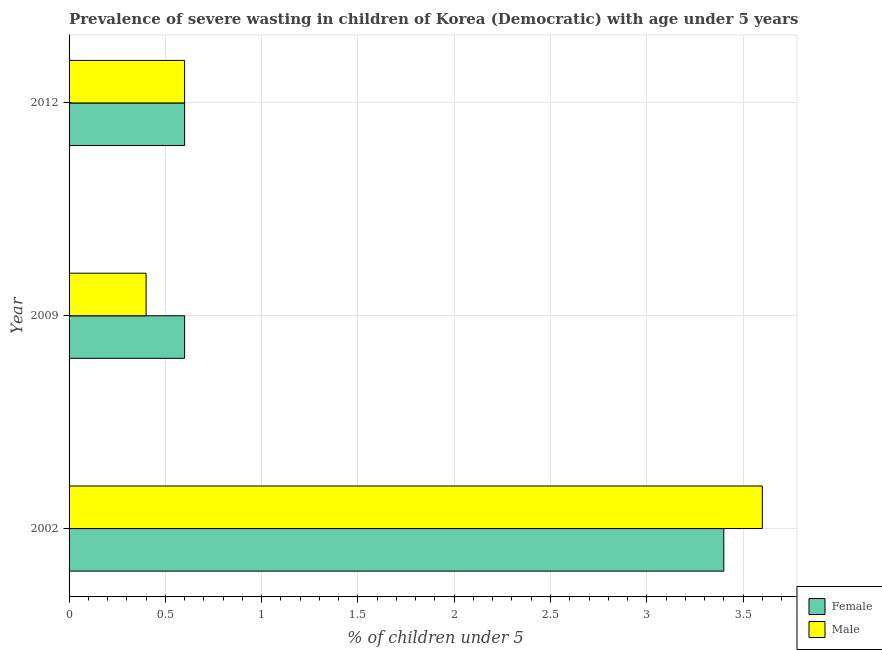How many different coloured bars are there?
Provide a short and direct response. 2. What is the label of the 2nd group of bars from the top?
Your answer should be compact. 2009. What is the percentage of undernourished female children in 2012?
Give a very brief answer. 0.6. Across all years, what is the maximum percentage of undernourished female children?
Give a very brief answer. 3.4. Across all years, what is the minimum percentage of undernourished male children?
Keep it short and to the point. 0.4. In which year was the percentage of undernourished female children maximum?
Provide a short and direct response. 2002. What is the total percentage of undernourished male children in the graph?
Make the answer very short. 4.6. What is the difference between the percentage of undernourished female children in 2009 and the percentage of undernourished male children in 2002?
Make the answer very short. -3. What is the average percentage of undernourished male children per year?
Provide a short and direct response. 1.53. In the year 2009, what is the difference between the percentage of undernourished male children and percentage of undernourished female children?
Offer a very short reply. -0.2. Is the percentage of undernourished male children in 2002 less than that in 2009?
Provide a short and direct response. No. In how many years, is the percentage of undernourished male children greater than the average percentage of undernourished male children taken over all years?
Offer a very short reply. 1. Is the sum of the percentage of undernourished male children in 2009 and 2012 greater than the maximum percentage of undernourished female children across all years?
Ensure brevity in your answer.  No. How many bars are there?
Your answer should be very brief. 6. How many years are there in the graph?
Provide a short and direct response. 3. Are the values on the major ticks of X-axis written in scientific E-notation?
Give a very brief answer. No. Does the graph contain any zero values?
Ensure brevity in your answer.  No. Where does the legend appear in the graph?
Give a very brief answer. Bottom right. What is the title of the graph?
Your answer should be compact. Prevalence of severe wasting in children of Korea (Democratic) with age under 5 years. Does "2012 US$" appear as one of the legend labels in the graph?
Your response must be concise. No. What is the label or title of the X-axis?
Give a very brief answer.  % of children under 5. What is the  % of children under 5 of Female in 2002?
Your answer should be very brief. 3.4. What is the  % of children under 5 of Male in 2002?
Your response must be concise. 3.6. What is the  % of children under 5 of Female in 2009?
Give a very brief answer. 0.6. What is the  % of children under 5 in Male in 2009?
Your answer should be very brief. 0.4. What is the  % of children under 5 of Female in 2012?
Give a very brief answer. 0.6. What is the  % of children under 5 in Male in 2012?
Your answer should be very brief. 0.6. Across all years, what is the maximum  % of children under 5 in Female?
Your response must be concise. 3.4. Across all years, what is the maximum  % of children under 5 in Male?
Make the answer very short. 3.6. Across all years, what is the minimum  % of children under 5 in Female?
Provide a succinct answer. 0.6. Across all years, what is the minimum  % of children under 5 in Male?
Keep it short and to the point. 0.4. What is the total  % of children under 5 in Male in the graph?
Ensure brevity in your answer.  4.6. What is the difference between the  % of children under 5 of Female in 2002 and that in 2009?
Provide a short and direct response. 2.8. What is the difference between the  % of children under 5 in Male in 2002 and that in 2012?
Keep it short and to the point. 3. What is the difference between the  % of children under 5 of Female in 2009 and that in 2012?
Keep it short and to the point. 0. What is the difference between the  % of children under 5 of Male in 2009 and that in 2012?
Your answer should be very brief. -0.2. What is the difference between the  % of children under 5 of Female in 2002 and the  % of children under 5 of Male in 2012?
Ensure brevity in your answer.  2.8. What is the difference between the  % of children under 5 in Female in 2009 and the  % of children under 5 in Male in 2012?
Provide a short and direct response. 0. What is the average  % of children under 5 of Female per year?
Make the answer very short. 1.53. What is the average  % of children under 5 in Male per year?
Provide a short and direct response. 1.53. In the year 2002, what is the difference between the  % of children under 5 in Female and  % of children under 5 in Male?
Your answer should be compact. -0.2. What is the ratio of the  % of children under 5 of Female in 2002 to that in 2009?
Keep it short and to the point. 5.67. What is the ratio of the  % of children under 5 of Male in 2002 to that in 2009?
Your answer should be compact. 9. What is the ratio of the  % of children under 5 of Female in 2002 to that in 2012?
Offer a very short reply. 5.67. What is the ratio of the  % of children under 5 of Male in 2002 to that in 2012?
Give a very brief answer. 6. What is the ratio of the  % of children under 5 in Male in 2009 to that in 2012?
Your answer should be compact. 0.67. What is the difference between the highest and the second highest  % of children under 5 of Female?
Ensure brevity in your answer.  2.8. What is the difference between the highest and the lowest  % of children under 5 in Female?
Make the answer very short. 2.8. 